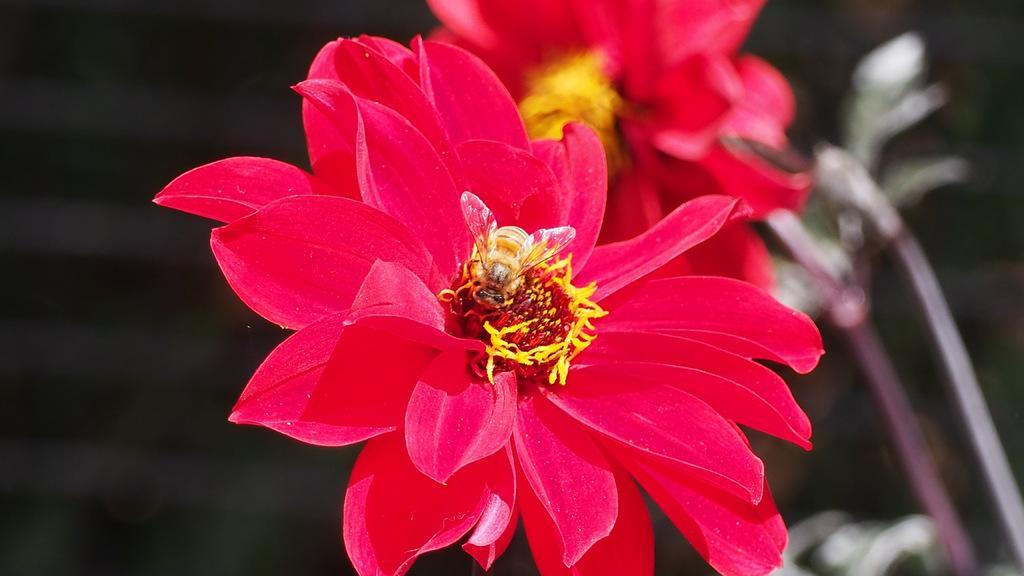In one or two sentences, can you explain what this image depicts? In this image I can see the flowers. In the background, I can see the plants. 